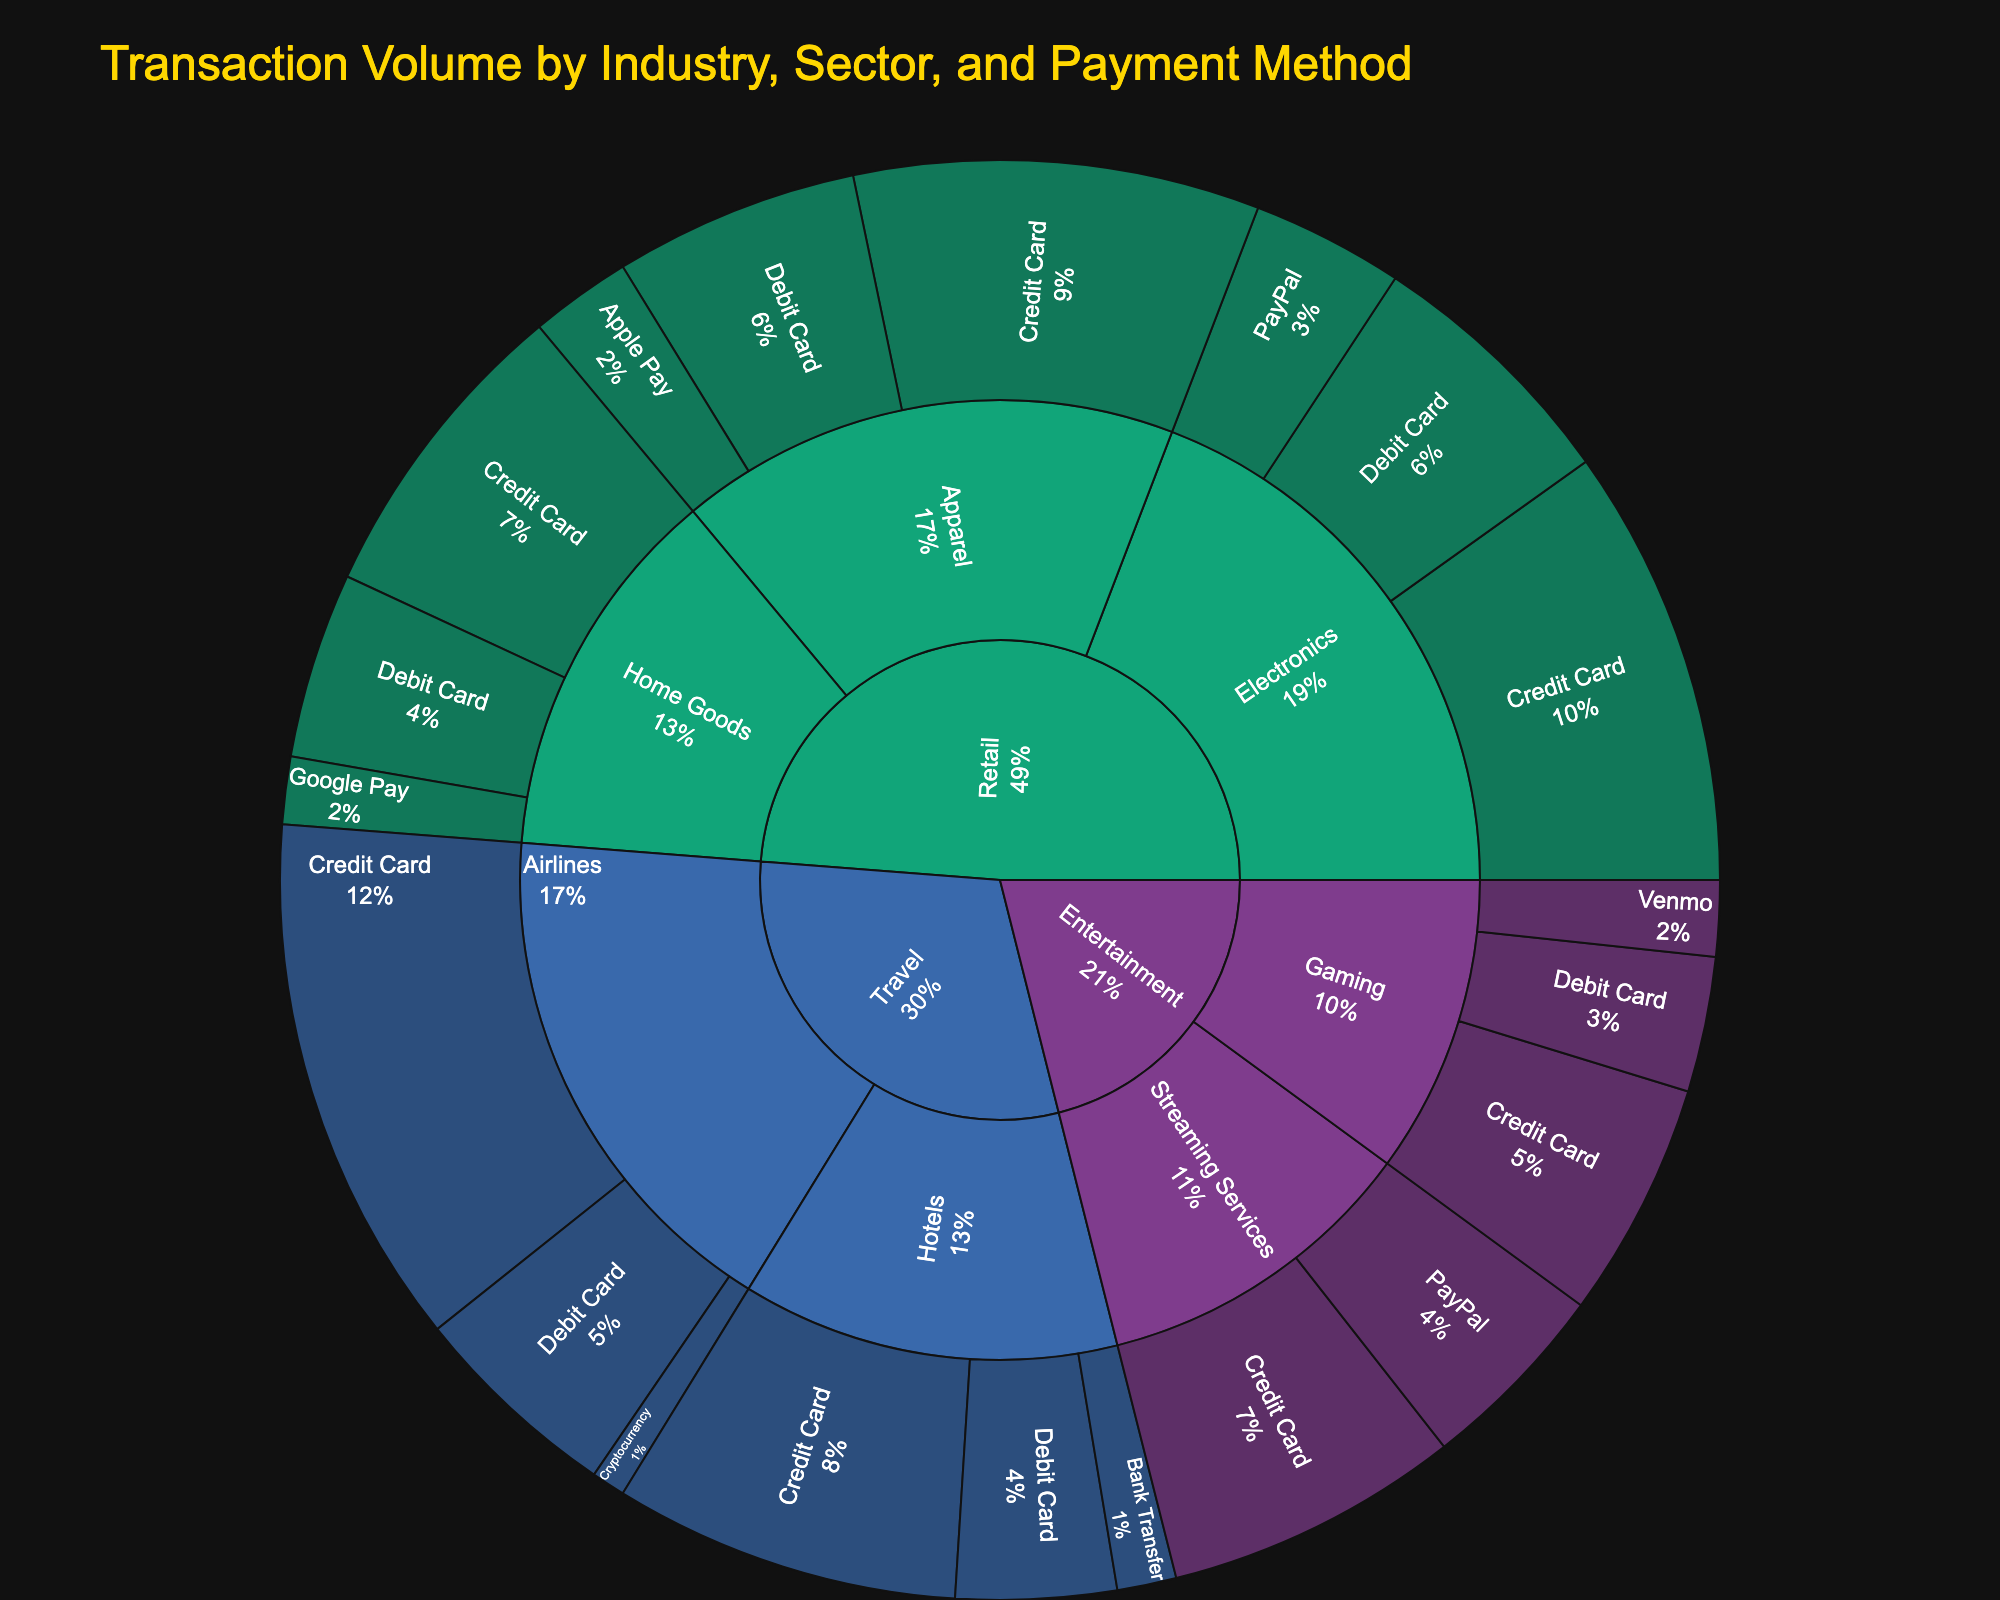How many sectors are represented in the Retail industry? The Retail industry includes three sectors: Electronics, Apparel, and Home Goods. This can be seen by identifying the segments directly connected to the Retail section in the sunburst plot.
Answer: 3 Which payment method has the highest transaction volume in the Travel industry? In the Travel industry, look for the segment with the largest area under the Travel section and note the associated payment method. Credit Card has the largest volume.
Answer: Credit Card Across all industries, which sector has the lowest total transaction volume? Examine all sectors in the sunburst plot and compare their total transaction volumes by summing up the volumes of their respective payment methods. "Hotels" in the Travel industry has the smallest combined volume.
Answer: Hotels What is the total transaction volume for the Entertainment industry? Sum up the volumes of all payment methods under both sectors (Streaming Services and Gaming) in the Entertainment industry. This can be calculated by adding the volumes: 3500000 + 2300000 + 2800000 + 1600000 + 900000.
Answer: $11,500,000 Is the transaction volume for PayPal higher in the Retail or Entertainment industry? Compare the volumes of PayPal within the Retail industry (1,800,000 for Electronics only) and the Entertainment industry (2,300,000 for Streaming Services only).
Answer: Entertainment Which industry has the highest transaction volume using Debit Card? Identify and sum the Debit Card volumes for each industry, then compare these sums. Retail industry has a total of 3,100,000 (Electronics) + 2,900,000 (Apparel) + 2,200,000 (Home Goods) = 8,200,000. Travel industry has 2,500,000 (Airlines) + 1,900,000 (Hotels) = 4,400,000. Entertainment industry has 1,600,000 (Gaming). Therefore, Retail has the highest volume.
Answer: Retail What percentage of the total transaction volume in the Home Goods sector comes from Google Pay? First, find the total transaction volume for Home Goods (3,700,000 + 2,200,000 + 800,000). Then, calculate the percentage for Google Pay (800,000 / (3,700,000 + 2,200,000 + 800,000) * 100).
Answer: 10.4% Which sector in the Retail industry has the largest volume of transactions with Credit Card? Compare the Credit Card transaction volumes of Electronics (5,200,000), Apparel (4,800,000), and Home Goods (3,700,000) under Retail. Electronics has the largest volume.
Answer: Electronics Does the Travel industry have a higher total transaction volume than the Entertainment industry? Sum the transaction volumes of all sectors and payment methods in the Travel (6,300,000 + 2,500,000 + 400,000 + 4,100,000 + 1,900,000 + 700,000) and Entertainment (3,500,000 + 2,300,000 + 2,800,000 + 1,600,000 + 900,000) industries, then compare the totals. Travel’s total (15,900,000) is higher than Entertainment’s total (11,100,000).
Answer: Yes 